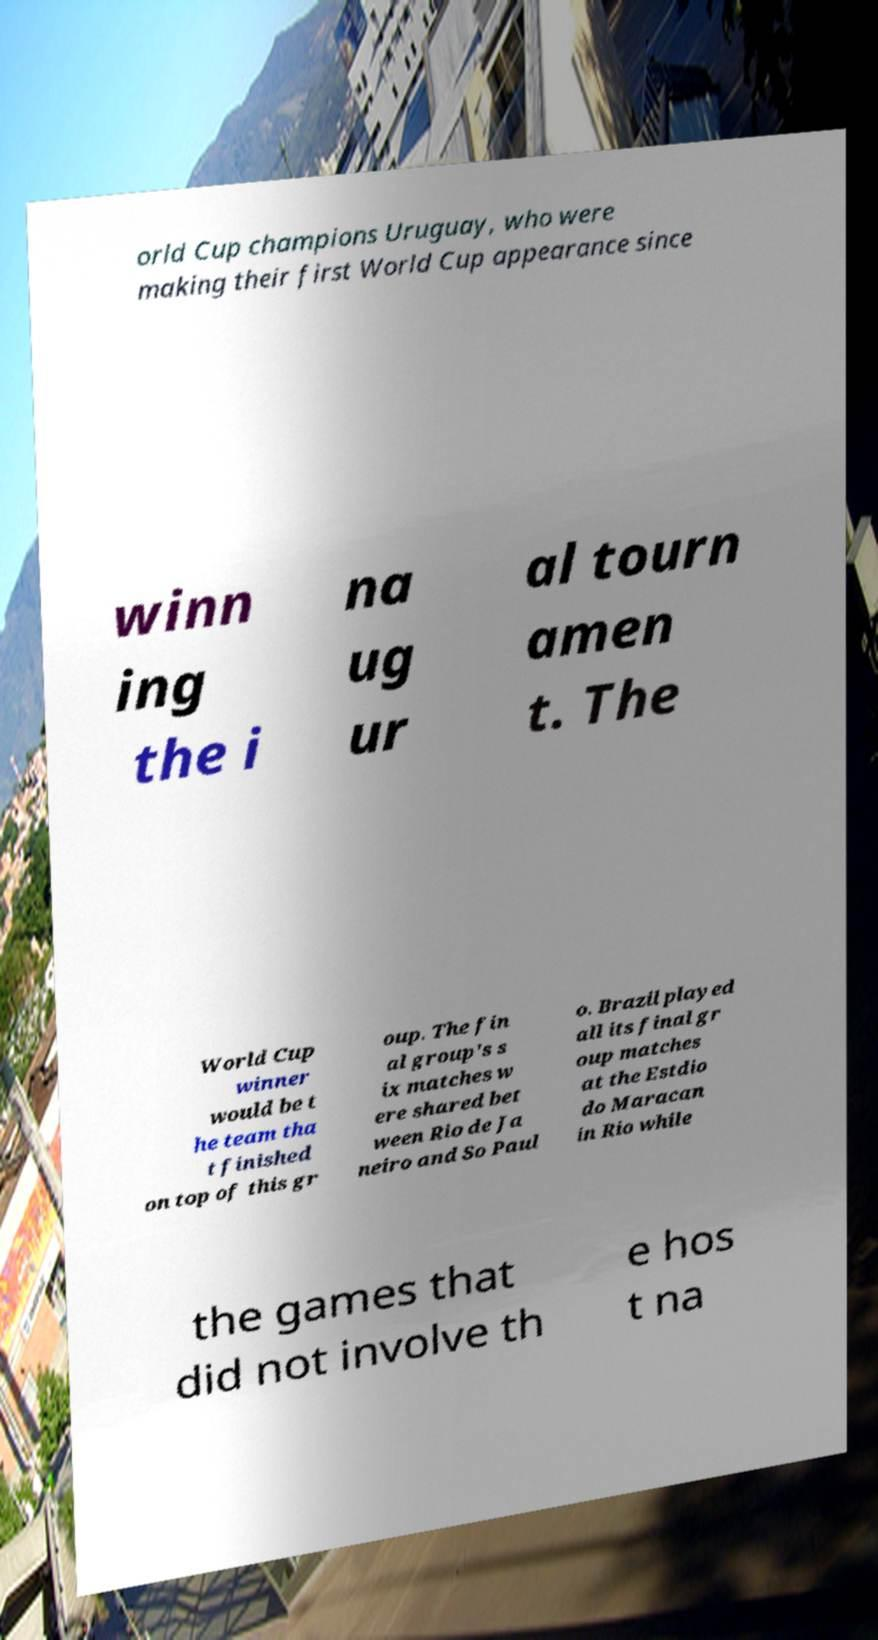What messages or text are displayed in this image? I need them in a readable, typed format. orld Cup champions Uruguay, who were making their first World Cup appearance since winn ing the i na ug ur al tourn amen t. The World Cup winner would be t he team tha t finished on top of this gr oup. The fin al group's s ix matches w ere shared bet ween Rio de Ja neiro and So Paul o. Brazil played all its final gr oup matches at the Estdio do Maracan in Rio while the games that did not involve th e hos t na 